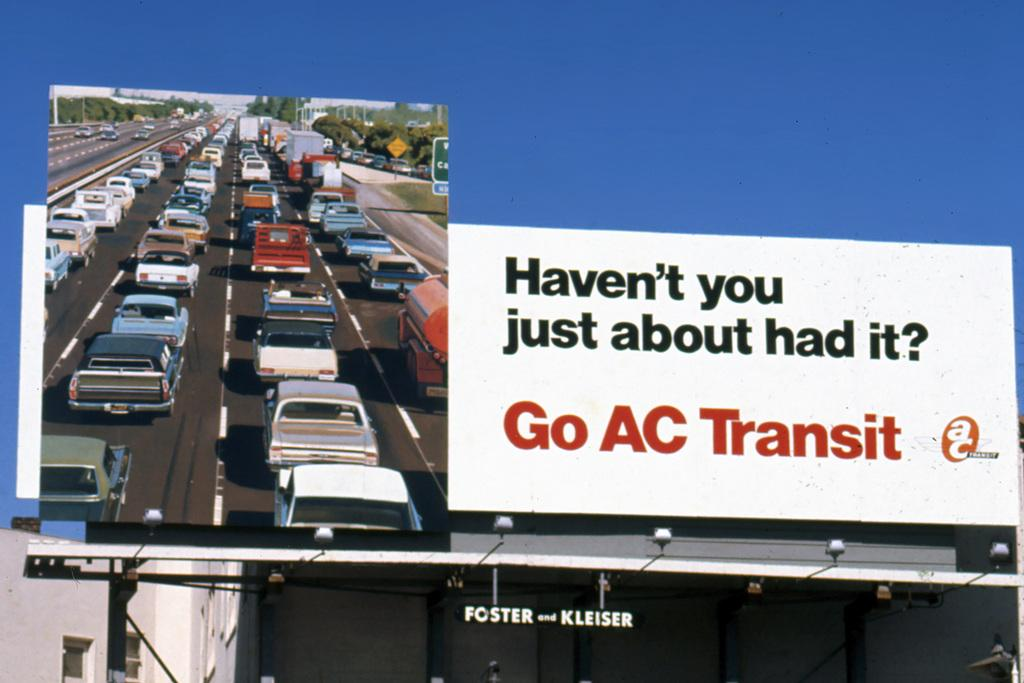<image>
Summarize the visual content of the image. A billboard of Go AC Transit depicting heavy traffic on one side and the question: Heven't you just about had it?" on the other. 